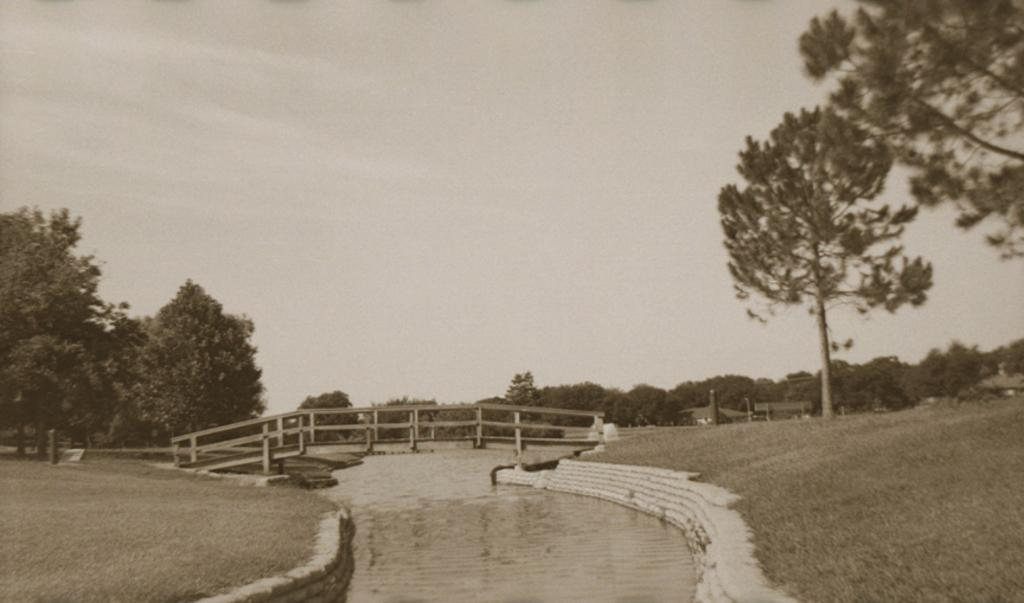What is the main subject in the foreground of the image? There is a bridge in the foreground of the image. What is the bridge positioned over? The bridge is over a river. What type of vegetation can be seen on the right side of the image? There are trees and grass on the right side of the image. What type of vegetation can be seen on the left side of the image? There are trees and grass on the left side of the image. What part of the natural environment is visible on the left side of the image? The sky is visible on the left side of the image. Can you see any oranges growing on the trees in the image? There are no oranges visible in the image; the trees are not specified as fruit-bearing trees. Is there an ocean visible in the image? No, there is no ocean visible in the image; it features a river and surrounding vegetation. 